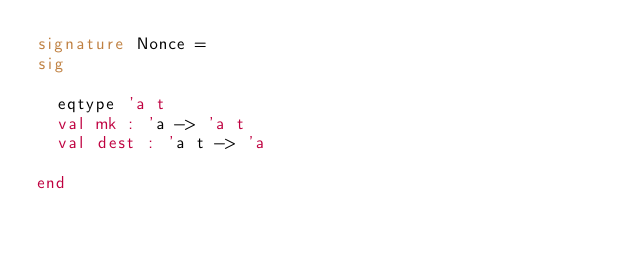<code> <loc_0><loc_0><loc_500><loc_500><_SML_>signature Nonce =
sig

  eqtype 'a t
  val mk : 'a -> 'a t
  val dest : 'a t -> 'a

end


</code> 